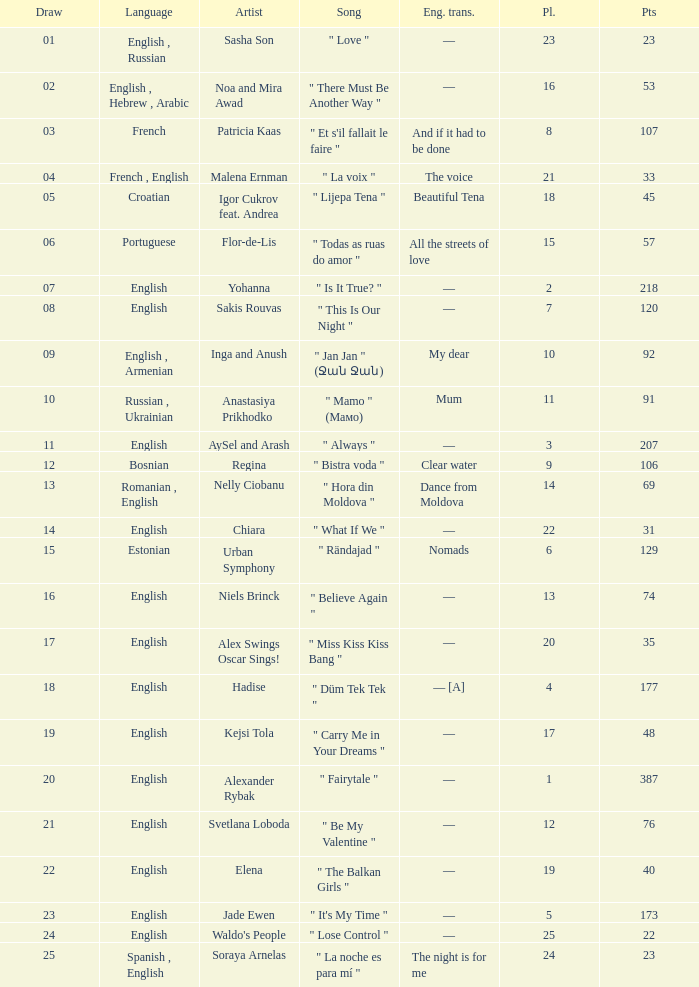What was the english translation for the song by svetlana loboda? —. 